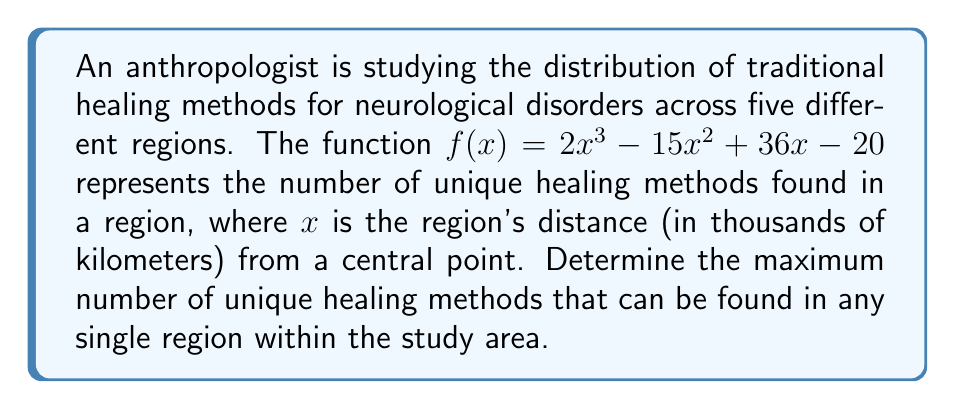Show me your answer to this math problem. To find the maximum number of unique healing methods, we need to find the maximum value of the function $f(x) = 2x^3 - 15x^2 + 36x - 20$ within the relevant domain.

Step 1: Find the critical points by taking the derivative and setting it equal to zero.
$$f'(x) = 6x^2 - 30x + 36$$
$$6x^2 - 30x + 36 = 0$$

Step 2: Solve the quadratic equation.
$$x = \frac{30 \pm \sqrt{900 - 864}}{12} = \frac{30 \pm \sqrt{36}}{12} = \frac{30 \pm 6}{12}$$

This gives us two critical points:
$$x_1 = \frac{30 + 6}{12} = 3$$
$$x_2 = \frac{30 - 6}{12} = 2$$

Step 3: Evaluate $f(x)$ at the critical points and at the endpoints of the relevant domain (assuming the domain is $[0, \infty)$ since distance cannot be negative).

At $x = 0$:
$$f(0) = 2(0)^3 - 15(0)^2 + 36(0) - 20 = -20$$

At $x = 2$:
$$f(2) = 2(2)^3 - 15(2)^2 + 36(2) - 20 = 16 - 60 + 72 - 20 = 8$$

At $x = 3$:
$$f(3) = 2(3)^3 - 15(3)^2 + 36(3) - 20 = 54 - 135 + 108 - 20 = 7$$

Step 4: Compare the values to find the maximum.

The maximum value among these points is 8, which occurs at $x = 2$.
Answer: The maximum number of unique healing methods that can be found in any single region is 8. 